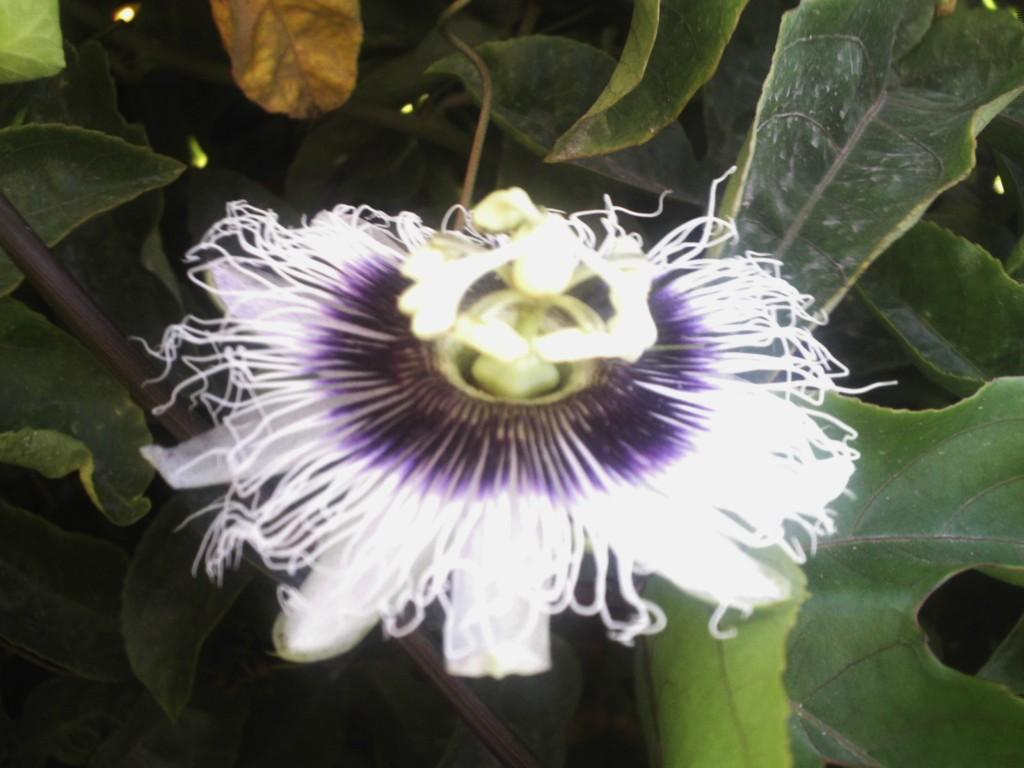What types of living organisms can be seen in the image? Plants and flowers are visible in the image. Can you describe the flowers in the image? The flowers in the image are colorful and appear to be in bloom. What historical event is depicted in the image involving a worm? There is no historical event or worm depicted in the image; it features plants and flowers. 